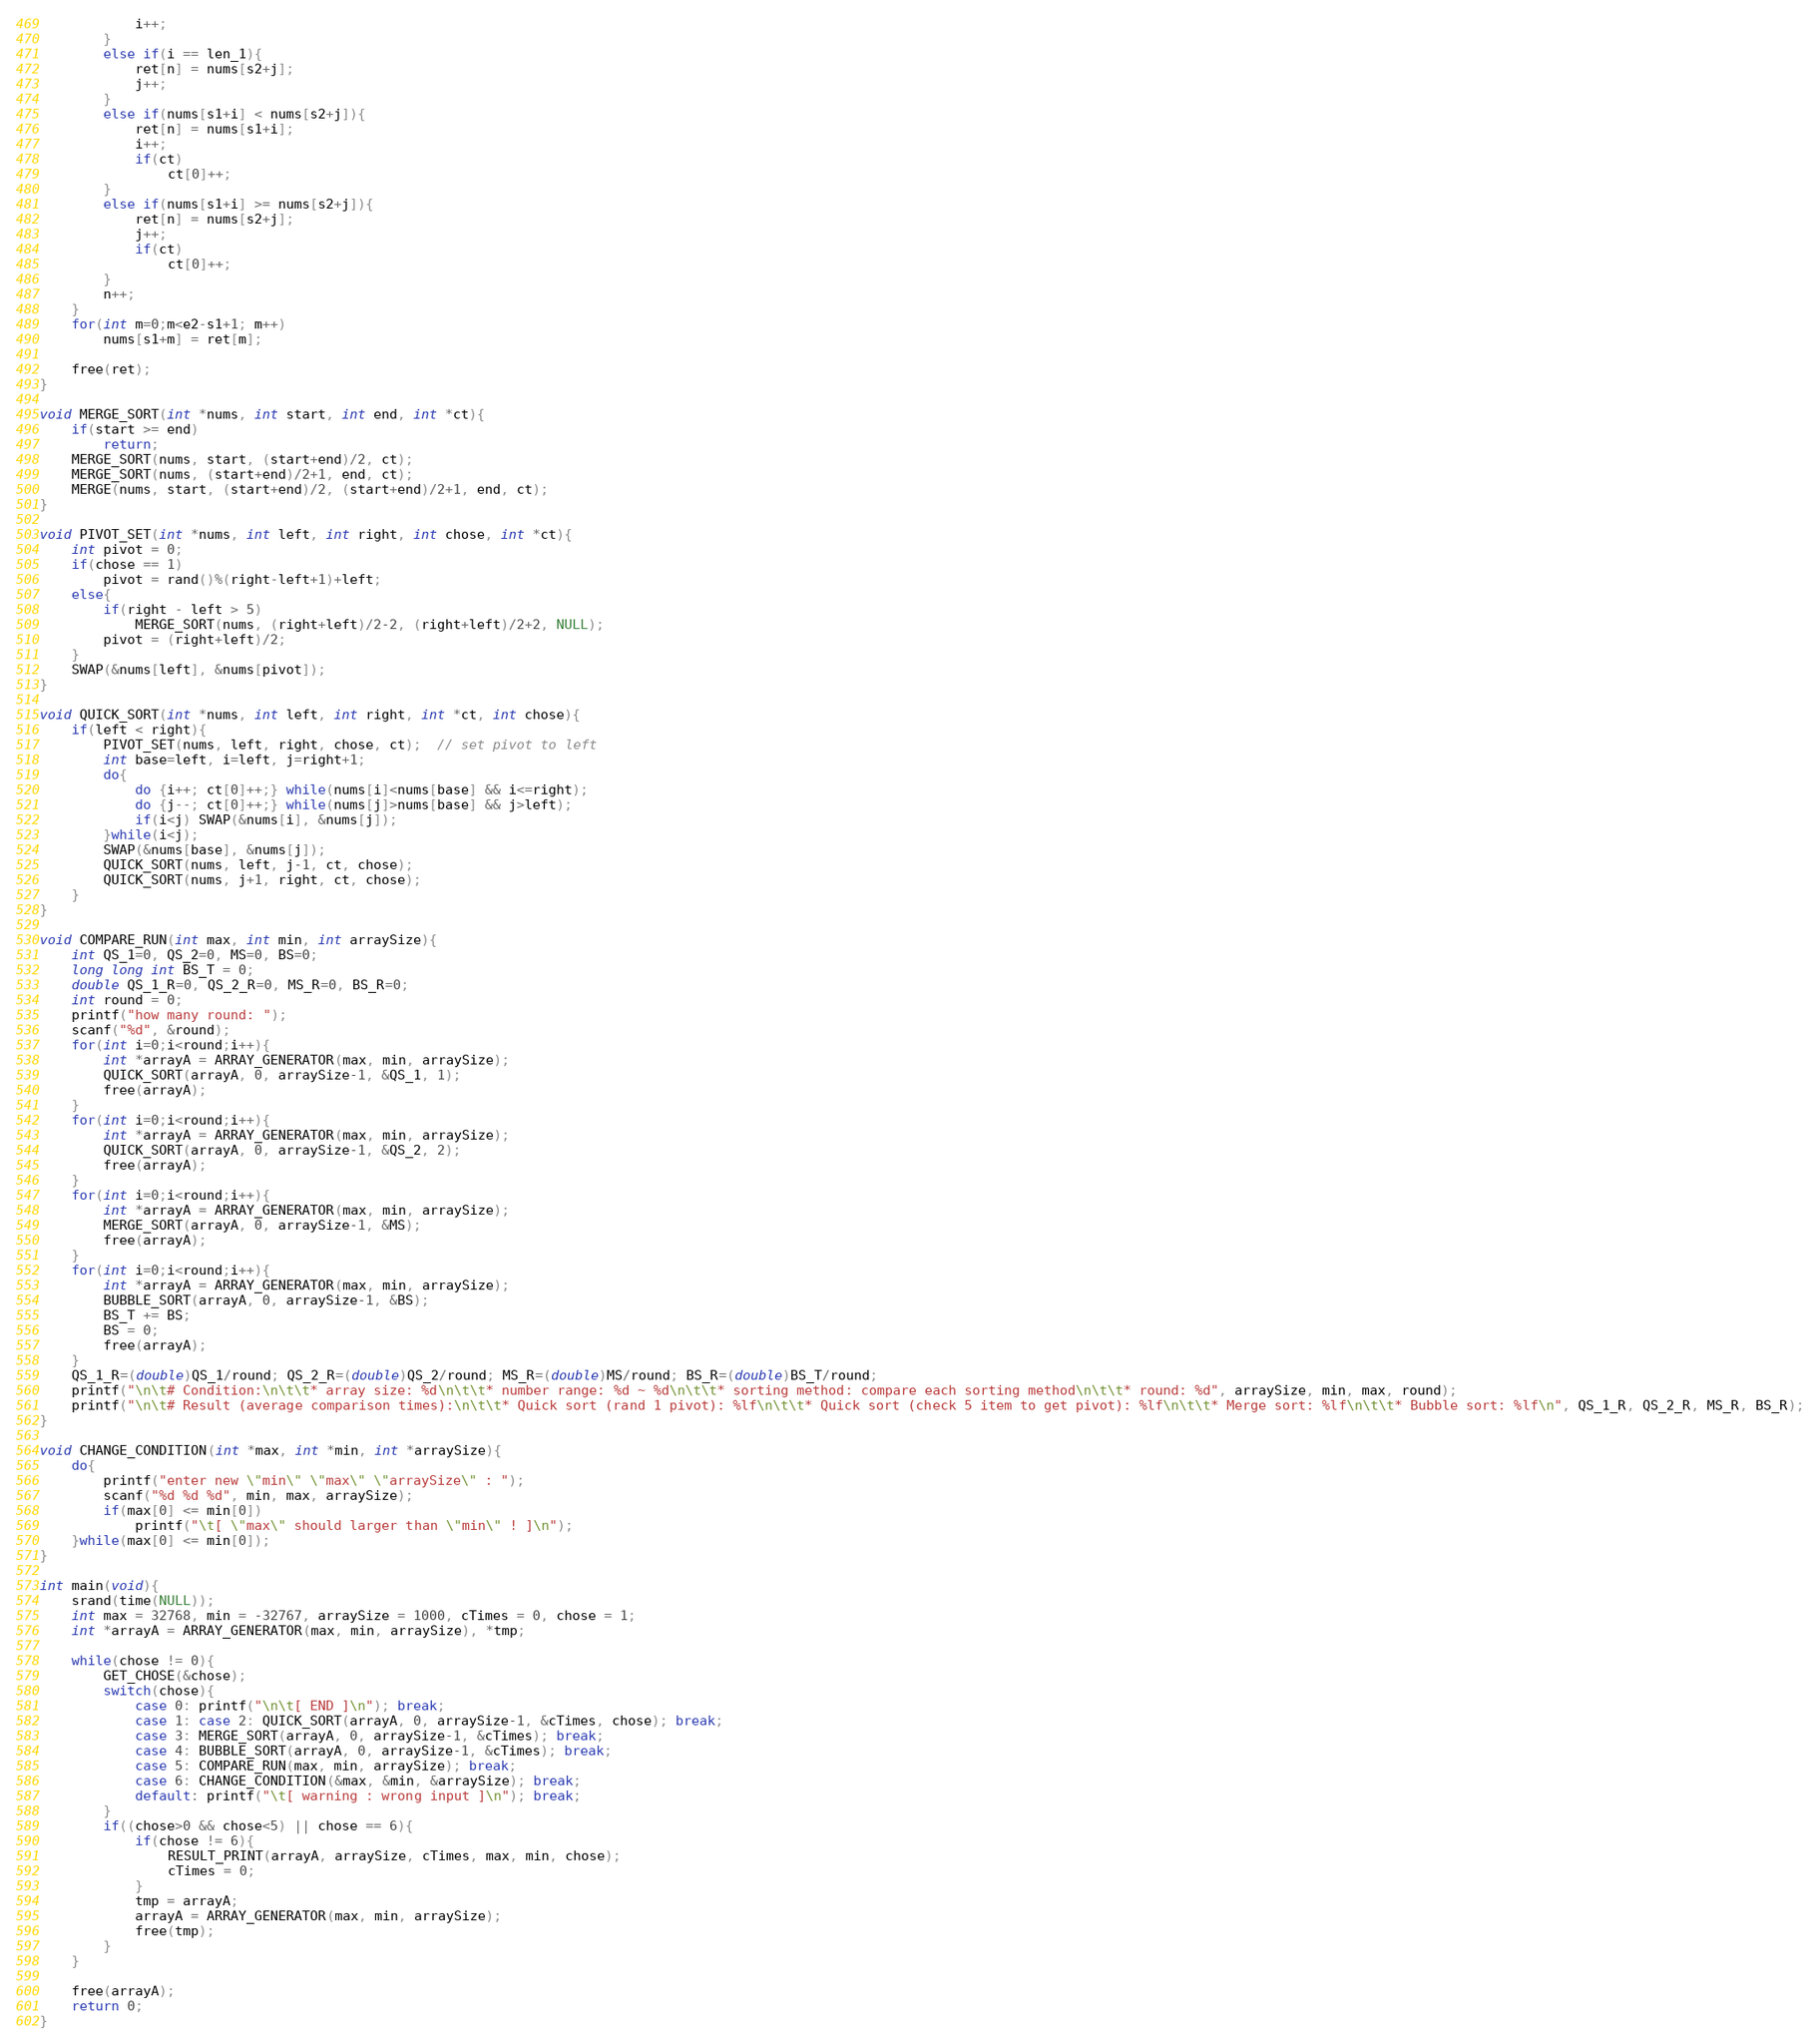<code> <loc_0><loc_0><loc_500><loc_500><_C++_>            i++;            
        }
        else if(i == len_1){
            ret[n] = nums[s2+j];
            j++; 
        }
        else if(nums[s1+i] < nums[s2+j]){
            ret[n] = nums[s1+i];
            i++;
            if(ct)
                ct[0]++;
        }
        else if(nums[s1+i] >= nums[s2+j]){
            ret[n] = nums[s2+j];
            j++;
            if(ct)   
                ct[0]++;         
        }
        n++;             
    }
    for(int m=0;m<e2-s1+1; m++)
        nums[s1+m] = ret[m];
    
    free(ret);
}

void MERGE_SORT(int *nums, int start, int end, int *ct){
    if(start >= end)
        return;
    MERGE_SORT(nums, start, (start+end)/2, ct);
    MERGE_SORT(nums, (start+end)/2+1, end, ct);
    MERGE(nums, start, (start+end)/2, (start+end)/2+1, end, ct);
}

void PIVOT_SET(int *nums, int left, int right, int chose, int *ct){
    int pivot = 0;
    if(chose == 1)
        pivot = rand()%(right-left+1)+left;
    else{
        if(right - left > 5)
            MERGE_SORT(nums, (right+left)/2-2, (right+left)/2+2, NULL);
        pivot = (right+left)/2;
    }
    SWAP(&nums[left], &nums[pivot]);
}

void QUICK_SORT(int *nums, int left, int right, int *ct, int chose){
    if(left < right){
        PIVOT_SET(nums, left, right, chose, ct);  // set pivot to left
        int base=left, i=left, j=right+1;
        do{
            do {i++; ct[0]++;} while(nums[i]<nums[base] && i<=right); 
            do {j--; ct[0]++;} while(nums[j]>nums[base] && j>left); 
            if(i<j) SWAP(&nums[i], &nums[j]);
        }while(i<j);
        SWAP(&nums[base], &nums[j]);
        QUICK_SORT(nums, left, j-1, ct, chose);
        QUICK_SORT(nums, j+1, right, ct, chose);
    }
}

void COMPARE_RUN(int max, int min, int arraySize){
    int QS_1=0, QS_2=0, MS=0, BS=0;
    long long int BS_T = 0;
    double QS_1_R=0, QS_2_R=0, MS_R=0, BS_R=0;
    int round = 0;
    printf("how many round: ");
    scanf("%d", &round);
    for(int i=0;i<round;i++){
        int *arrayA = ARRAY_GENERATOR(max, min, arraySize);
        QUICK_SORT(arrayA, 0, arraySize-1, &QS_1, 1);
        free(arrayA);
    }
    for(int i=0;i<round;i++){
        int *arrayA = ARRAY_GENERATOR(max, min, arraySize);
        QUICK_SORT(arrayA, 0, arraySize-1, &QS_2, 2);
        free(arrayA);
    }
    for(int i=0;i<round;i++){
        int *arrayA = ARRAY_GENERATOR(max, min, arraySize);
        MERGE_SORT(arrayA, 0, arraySize-1, &MS);
        free(arrayA);
    }
    for(int i=0;i<round;i++){
        int *arrayA = ARRAY_GENERATOR(max, min, arraySize);
        BUBBLE_SORT(arrayA, 0, arraySize-1, &BS);
        BS_T += BS;
        BS = 0;
        free(arrayA);
    }
    QS_1_R=(double)QS_1/round; QS_2_R=(double)QS_2/round; MS_R=(double)MS/round; BS_R=(double)BS_T/round;
    printf("\n\t# Condition:\n\t\t* array size: %d\n\t\t* number range: %d ~ %d\n\t\t* sorting method: compare each sorting method\n\t\t* round: %d", arraySize, min, max, round);
    printf("\n\t# Result (average comparison times):\n\t\t* Quick sort (rand 1 pivot): %lf\n\t\t* Quick sort (check 5 item to get pivot): %lf\n\t\t* Merge sort: %lf\n\t\t* Bubble sort: %lf\n", QS_1_R, QS_2_R, MS_R, BS_R);
}

void CHANGE_CONDITION(int *max, int *min, int *arraySize){
    do{
        printf("enter new \"min\" \"max\" \"arraySize\" : ");
        scanf("%d %d %d", min, max, arraySize);
        if(max[0] <= min[0])
            printf("\t[ \"max\" should larger than \"min\" ! ]\n");
    }while(max[0] <= min[0]);
}

int main(void){  
    srand(time(NULL));  
    int max = 32768, min = -32767, arraySize = 1000, cTimes = 0, chose = 1;
    int *arrayA = ARRAY_GENERATOR(max, min, arraySize), *tmp;

    while(chose != 0){
        GET_CHOSE(&chose);
        switch(chose){
            case 0: printf("\n\t[ END ]\n"); break;
            case 1: case 2: QUICK_SORT(arrayA, 0, arraySize-1, &cTimes, chose); break;
            case 3: MERGE_SORT(arrayA, 0, arraySize-1, &cTimes); break;
            case 4: BUBBLE_SORT(arrayA, 0, arraySize-1, &cTimes); break;
            case 5: COMPARE_RUN(max, min, arraySize); break;
            case 6: CHANGE_CONDITION(&max, &min, &arraySize); break;
            default: printf("\t[ warning : wrong input ]\n"); break;
        }
        if((chose>0 && chose<5) || chose == 6){
            if(chose != 6){
                RESULT_PRINT(arrayA, arraySize, cTimes, max, min, chose);
                cTimes = 0;
            }
            tmp = arrayA;
            arrayA = ARRAY_GENERATOR(max, min, arraySize);
            free(tmp);
        }
    }

    free(arrayA);
    return 0;
}</code> 